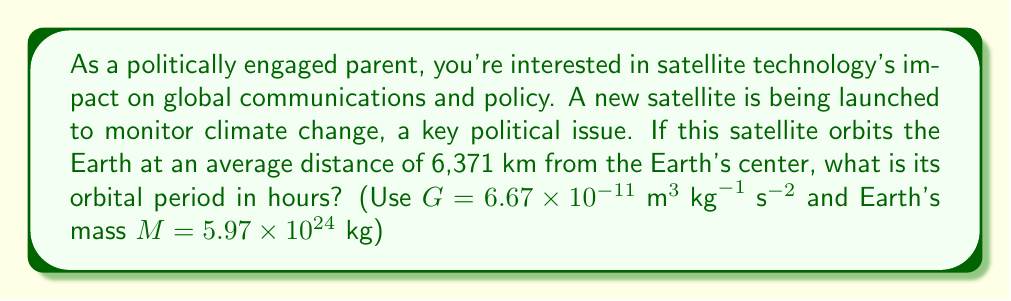Provide a solution to this math problem. To solve this problem, we'll use Kepler's Third Law of Planetary Motion, which relates the orbital period of a satellite to its semi-major axis. For circular orbits, the semi-major axis is equal to the radius of the orbit.

1) Kepler's Third Law in its general form is:

   $$T^2 = \frac{4\pi^2}{GM}r^3$$

   Where:
   $T$ is the orbital period
   $G$ is the gravitational constant
   $M$ is the mass of the central body (Earth in this case)
   $r$ is the radius of the orbit

2) Let's substitute the known values:
   $G = 6.67 \times 10^{-11} \text{ m}^3 \text{ kg}^{-1} \text{ s}^{-2}$
   $M = 5.97 \times 10^{24} \text{ kg}$
   $r = 6,371,000 \text{ m}$ (convert km to m)

3) Plug these into the equation:

   $$T^2 = \frac{4\pi^2}{(6.67 \times 10^{-11})(5.97 \times 10^{24})}(6,371,000)^3$$

4) Simplify:

   $$T^2 = 5.46 \times 10^7 \text{ s}^2$$

5) Take the square root of both sides:

   $$T = \sqrt{5.46 \times 10^7} = 7,390 \text{ s}$$

6) Convert seconds to hours:

   $$T = 7,390 \text{ s} \times \frac{1 \text{ hour}}{3600 \text{ s}} = 2.05 \text{ hours}$$
Answer: 2.05 hours 